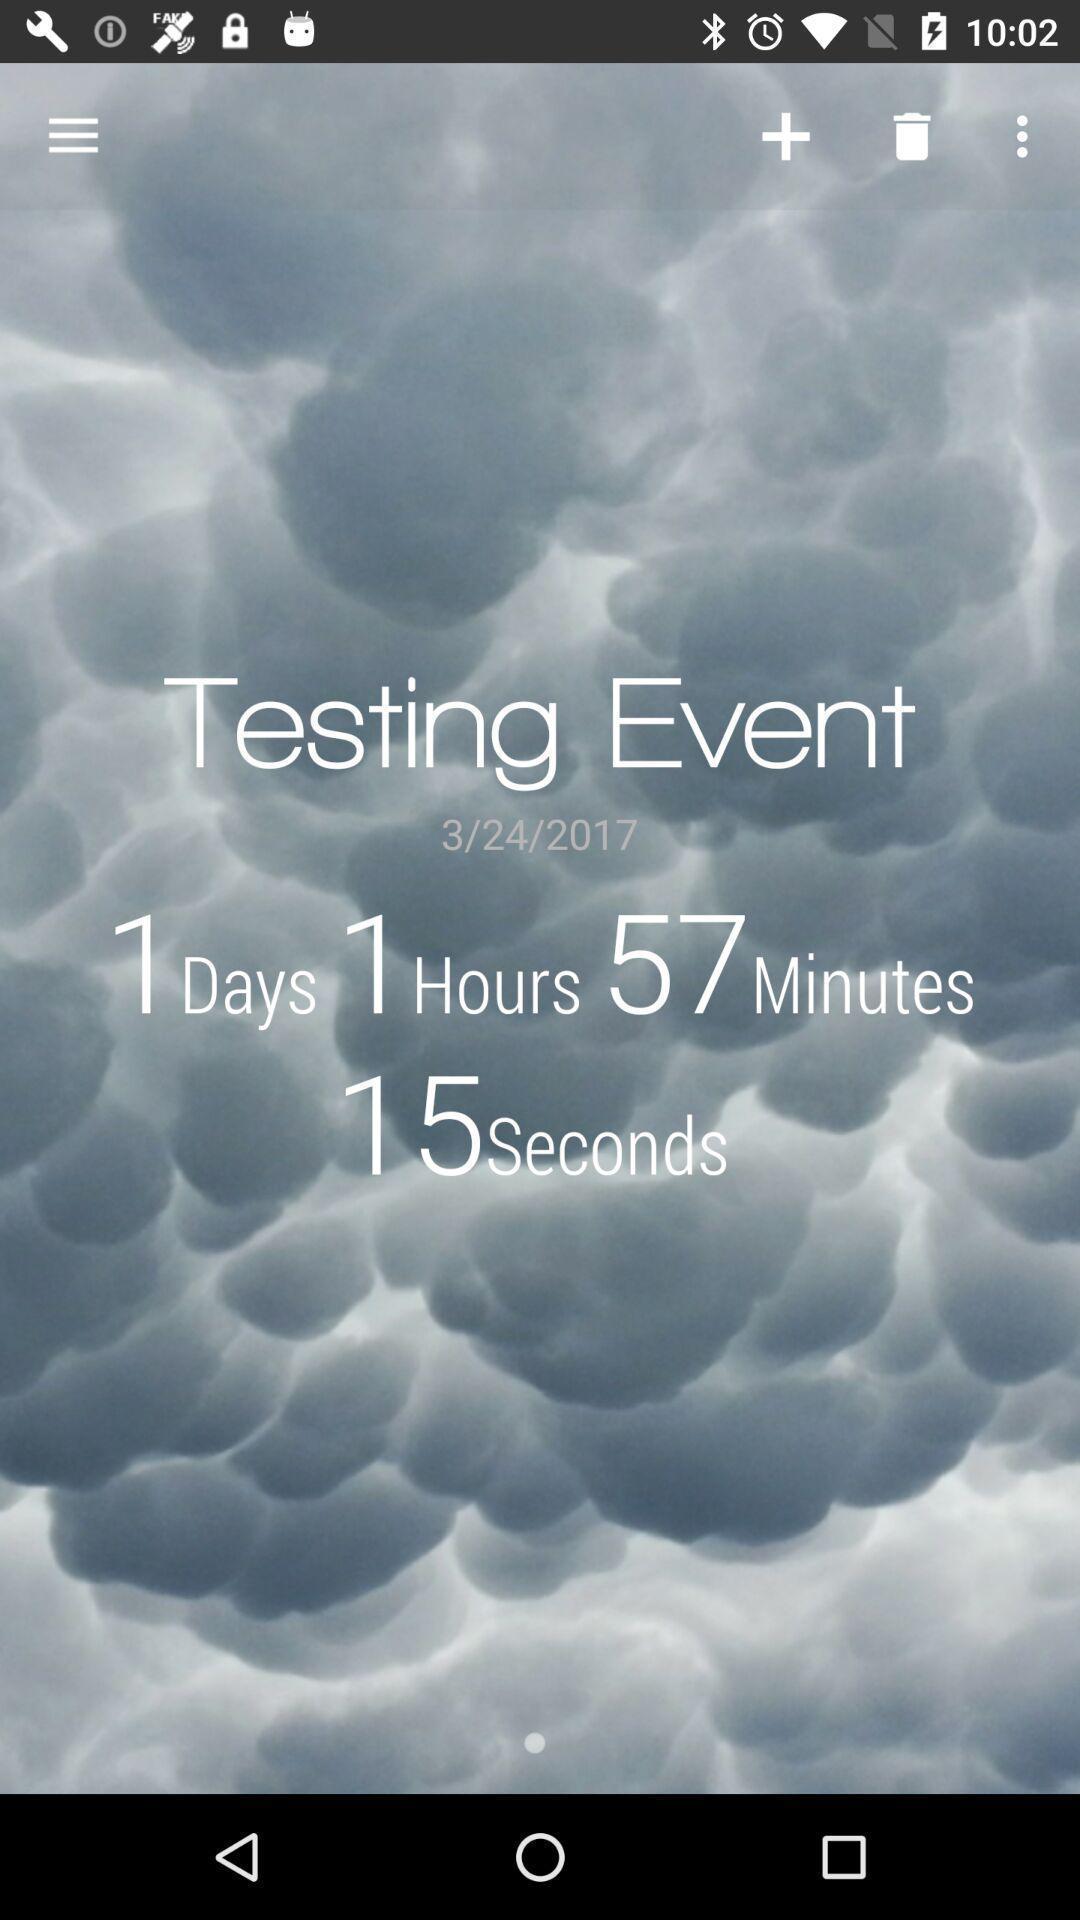Provide a textual representation of this image. Time running. 